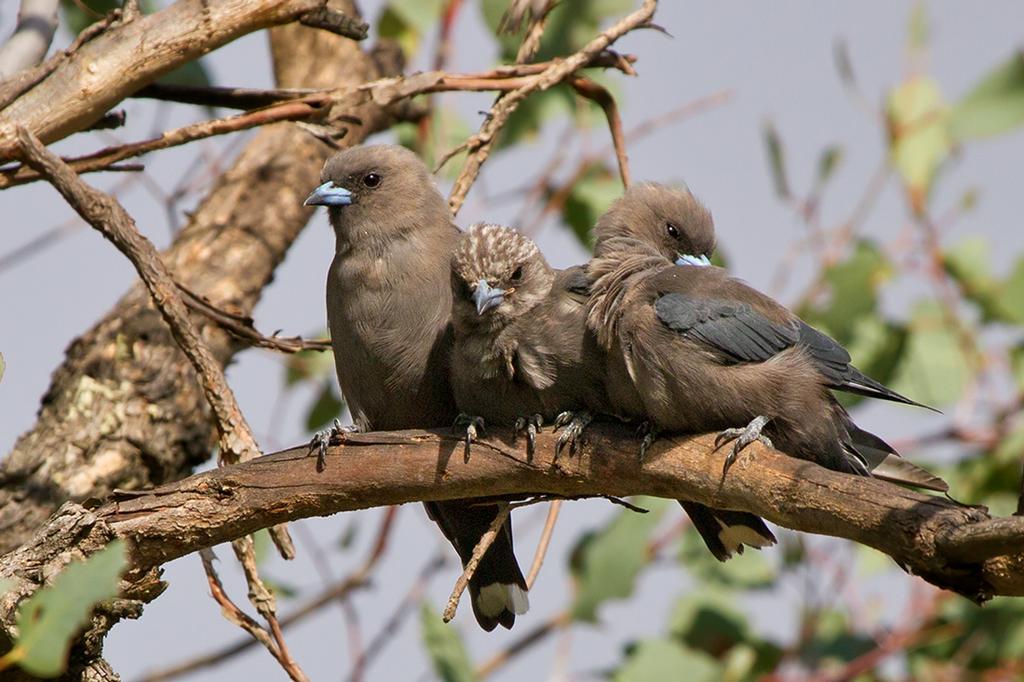Can you describe this image briefly? In this image in front there are three birds on the branch of a tree. In the background there is sky. 